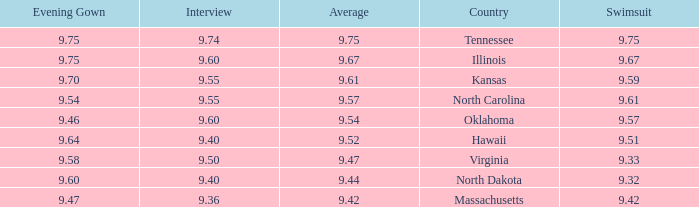Which country had an interview score of 9.40 and average of 9.44? North Dakota. 